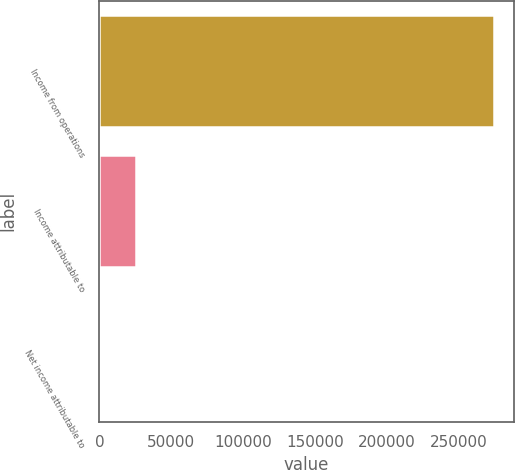Convert chart to OTSL. <chart><loc_0><loc_0><loc_500><loc_500><bar_chart><fcel>Income from operations<fcel>Income attributable to<fcel>Net income attributable to<nl><fcel>274307<fcel>25705<fcel>525<nl></chart> 